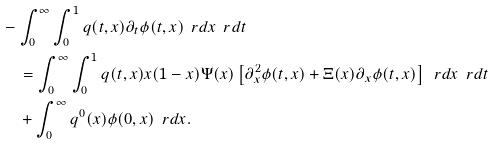Convert formula to latex. <formula><loc_0><loc_0><loc_500><loc_500>& - \int _ { 0 } ^ { \infty } \int _ { 0 } ^ { 1 } q ( t , x ) \partial _ { t } \phi ( t , x ) \, \ r d x \, \ r d t \\ & \quad = \int _ { 0 } ^ { \infty } \int _ { 0 } ^ { 1 } q ( t , x ) x ( 1 - x ) \Psi ( x ) \left [ \partial _ { x } ^ { 2 } \phi ( t , x ) + \Xi ( x ) \partial _ { x } \phi ( t , x ) \right ] \, \ r d x \, \ r d t \\ & \quad + \int _ { 0 } ^ { \infty } q ^ { 0 } ( x ) \phi ( 0 , x ) \, \ r d x .</formula> 